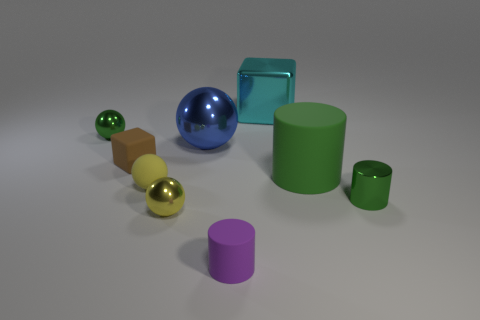What color is the small shiny thing that is to the left of the blue metallic object and on the right side of the small brown matte block?
Keep it short and to the point. Yellow. How many things are tiny green metallic things that are to the left of the small purple rubber cylinder or balls left of the blue ball?
Ensure brevity in your answer.  3. There is a small cylinder in front of the green shiny thing that is on the right side of the green metal thing that is behind the large blue shiny sphere; what is its color?
Your response must be concise. Purple. Are there any cyan metal objects that have the same shape as the brown matte thing?
Ensure brevity in your answer.  Yes. What number of tiny yellow spheres are there?
Make the answer very short. 2. The purple object has what shape?
Offer a terse response. Cylinder. What number of metal balls are the same size as the brown block?
Ensure brevity in your answer.  2. Is the big cyan object the same shape as the tiny brown object?
Your answer should be very brief. Yes. The block behind the ball behind the blue ball is what color?
Keep it short and to the point. Cyan. There is a shiny object that is right of the big blue sphere and in front of the yellow matte sphere; what is its size?
Your answer should be compact. Small. 